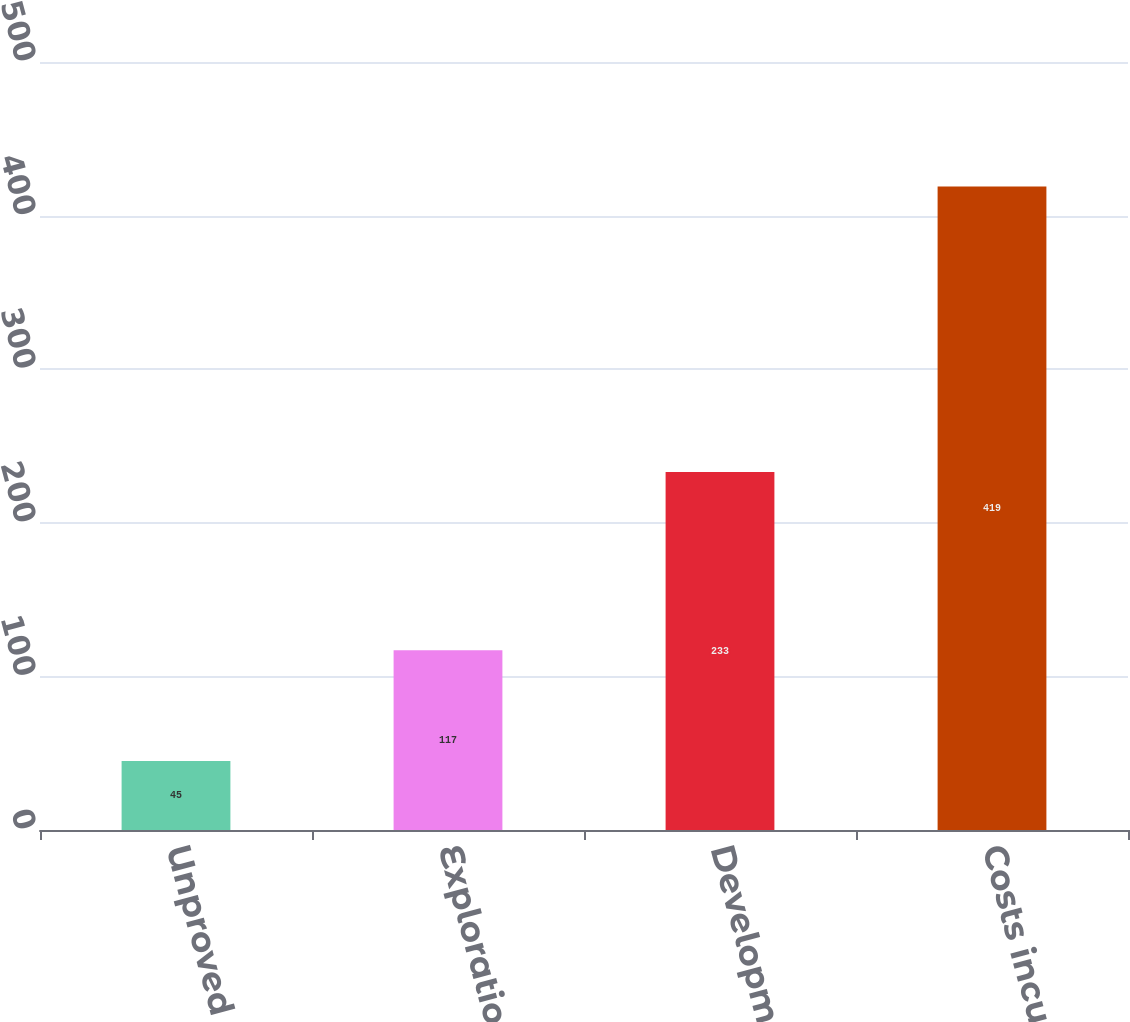Convert chart. <chart><loc_0><loc_0><loc_500><loc_500><bar_chart><fcel>Unproved properties<fcel>Exploration costs<fcel>Development costs<fcel>Costs incurred<nl><fcel>45<fcel>117<fcel>233<fcel>419<nl></chart> 